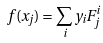<formula> <loc_0><loc_0><loc_500><loc_500>f ( x _ { j } ) = \sum _ { i } y _ { i } F ^ { i } _ { j }</formula> 